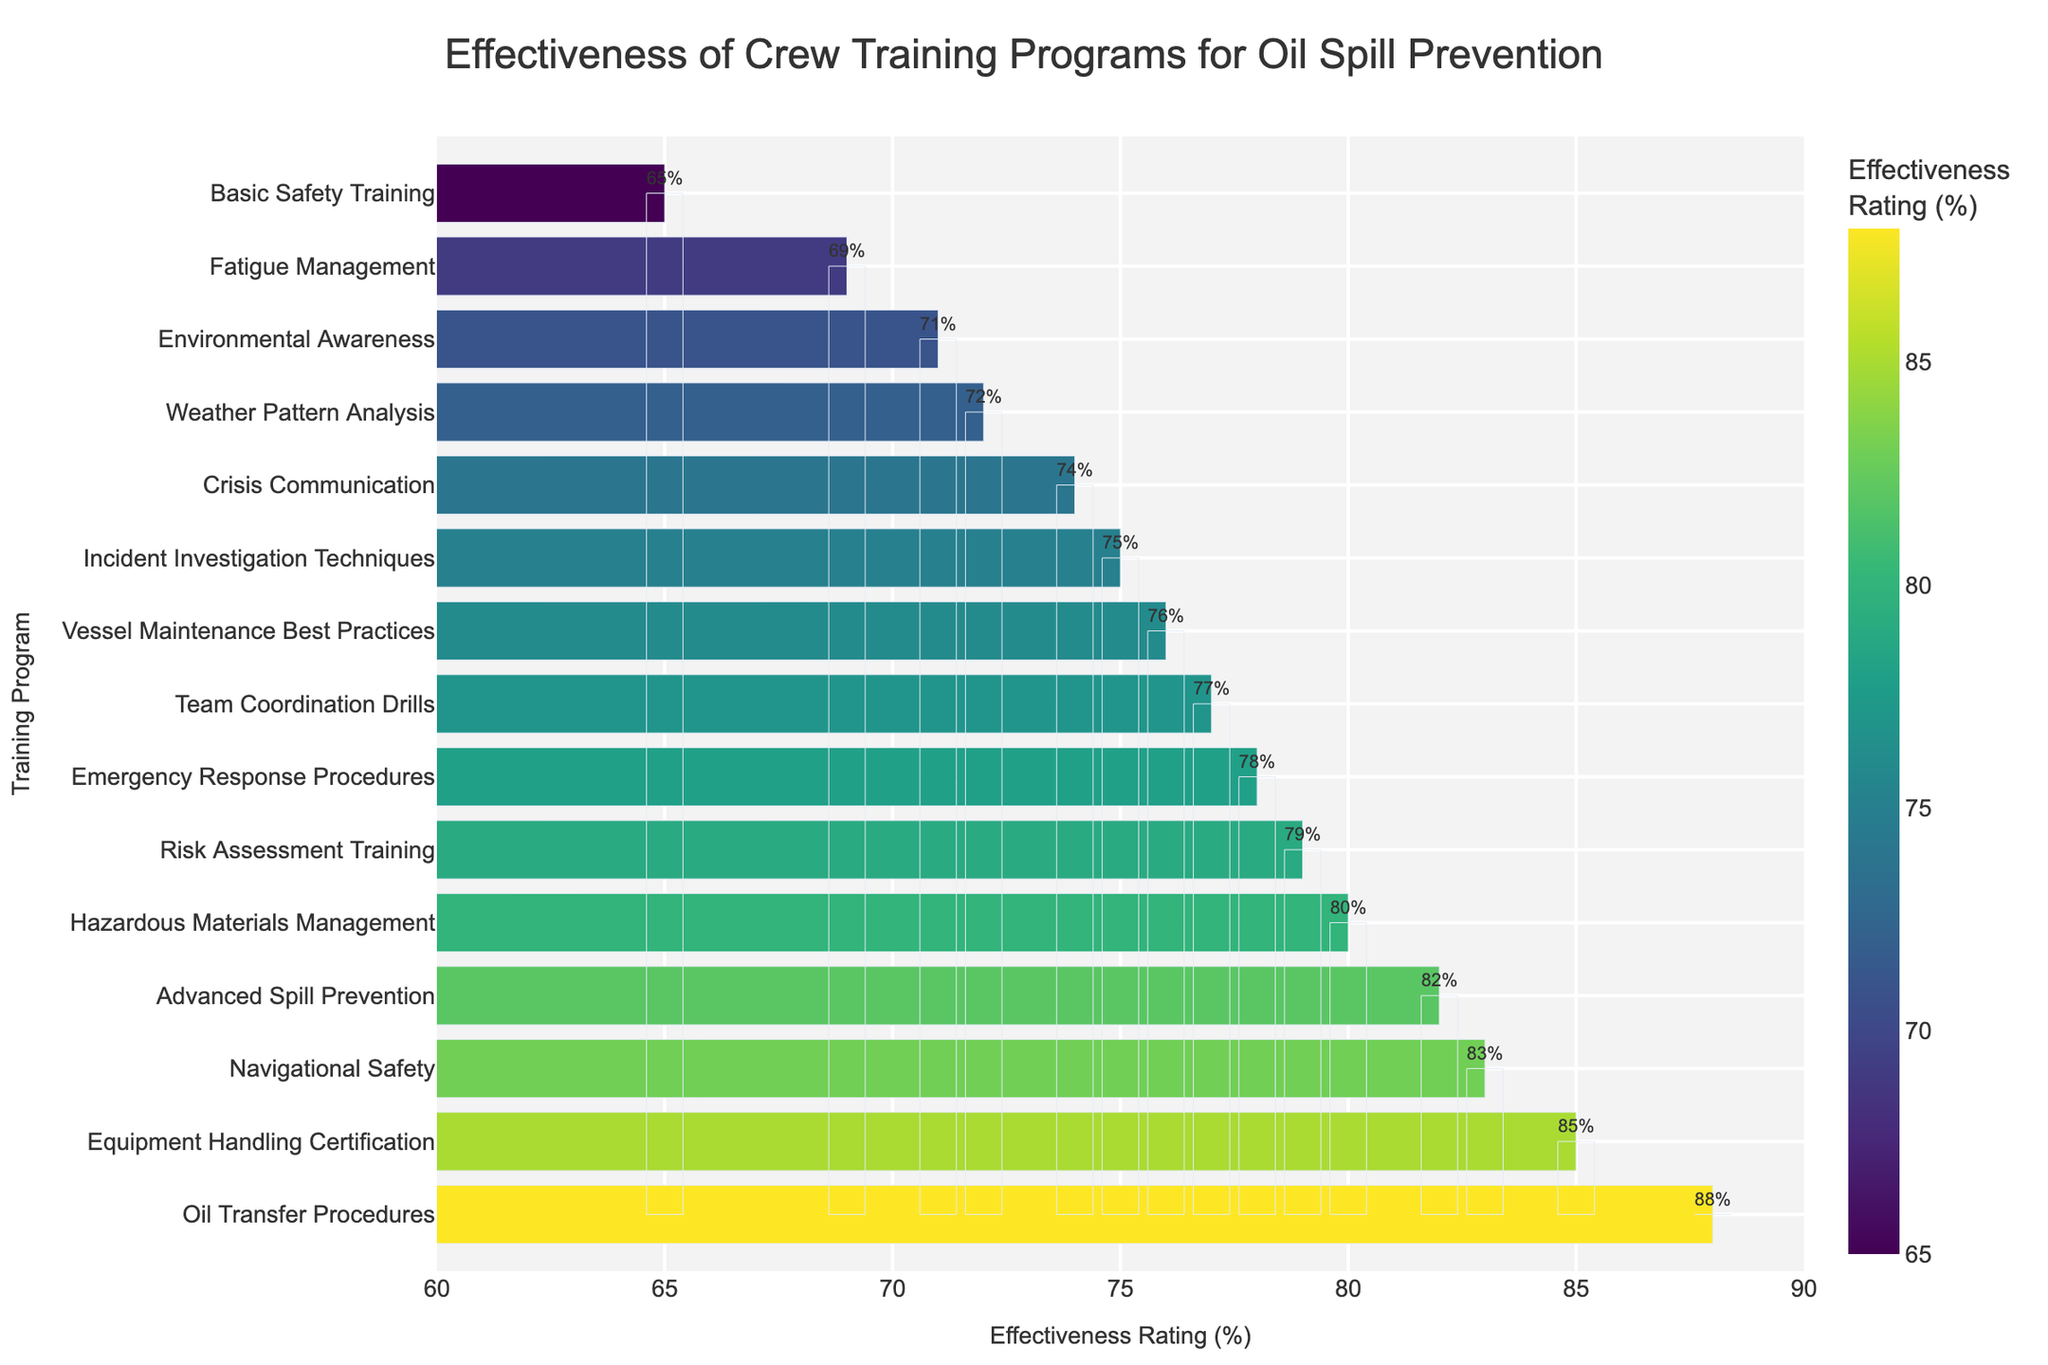What is the most effective training program for oil spill prevention according to the figure? To determine the most effective training program, identify the bar with the highest effectiveness rating. In this case, it is "Oil Transfer Procedures" with an 88% effectiveness rating.
Answer: Oil Transfer Procedures Which program has a higher effectiveness rating: Hazardous Materials Management or Fatigue Management? Compare the effectiveness ratings of both programs. Hazardous Materials Management has an 80% rating while Fatigue Management has a 69% rating.
Answer: Hazardous Materials Management What is the average effectiveness rating of Basic Safety Training, Environmental Awareness, and Crisis Communication programs? Compute the average of the effectiveness ratings of the three specified programs. Add the ratings: 65 (Basic Safety Training) + 71 (Environmental Awareness) + 74 (Crisis Communication) = 210. Then divide by 3: 210 / 3 = 70.
Answer: 70 Are there more programs with an effectiveness rating above 80% or below 70%? Count the programs with effectiveness above 80% and those below 70%. Above 80%: Advanced Spill Prevention, Equipment Handling Certification, Oil Transfer Procedures, Navigational Safety (4 programs). Below 70%: Basic Safety Training, Fatigue Management (2 programs).
Answer: Above 80% What is the difference in effectiveness ratings between the most and the least effective programs? Identify the highest and the lowest effectiveness ratings and subtract the latter from the former. Highest is 88% (Oil Transfer Procedures), and lowest is 65% (Basic Safety Training). The difference is 88 - 65 = 23.
Answer: 23 Which programs have effectiveness ratings within the range of 75% to 80%? Identify the bars that fall within the 75% to 80% range. These are Hazardous Materials Management (80%), Risk Assessment Training (79%), Team Coordination Drills (77%), Incident Investigation Techniques (75%).
Answer: Hazardous Materials Management, Risk Assessment Training, Team Coordination Drills, Incident Investigation Techniques How many programs have an effectiveness rating equal to or higher than 85%? Count the number of programs with effectiveness ratings of 85% or higher. These are Equipment Handling Certification (85%), Oil Transfer Procedures (88%), and Navigational Safety (83%). However, Navigational Safety is below 85%, so there are 2 programs.
Answer: 2 Is Crisis Communication more effective than Environmental Awareness? Compare the effectiveness ratings of both programs. Crisis Communication has a 74% rating, while Environmental Awareness has a 71% rating.
Answer: Yes What is the combined effectiveness rating of Team Coordination Drills and Incident Investigation Techniques? Add the effectiveness ratings of the two programs. Team Coordination Drills is 77%, and Incident Investigation Techniques is 75%. Combined: 77% + 75% = 152%.
Answer: 152% 